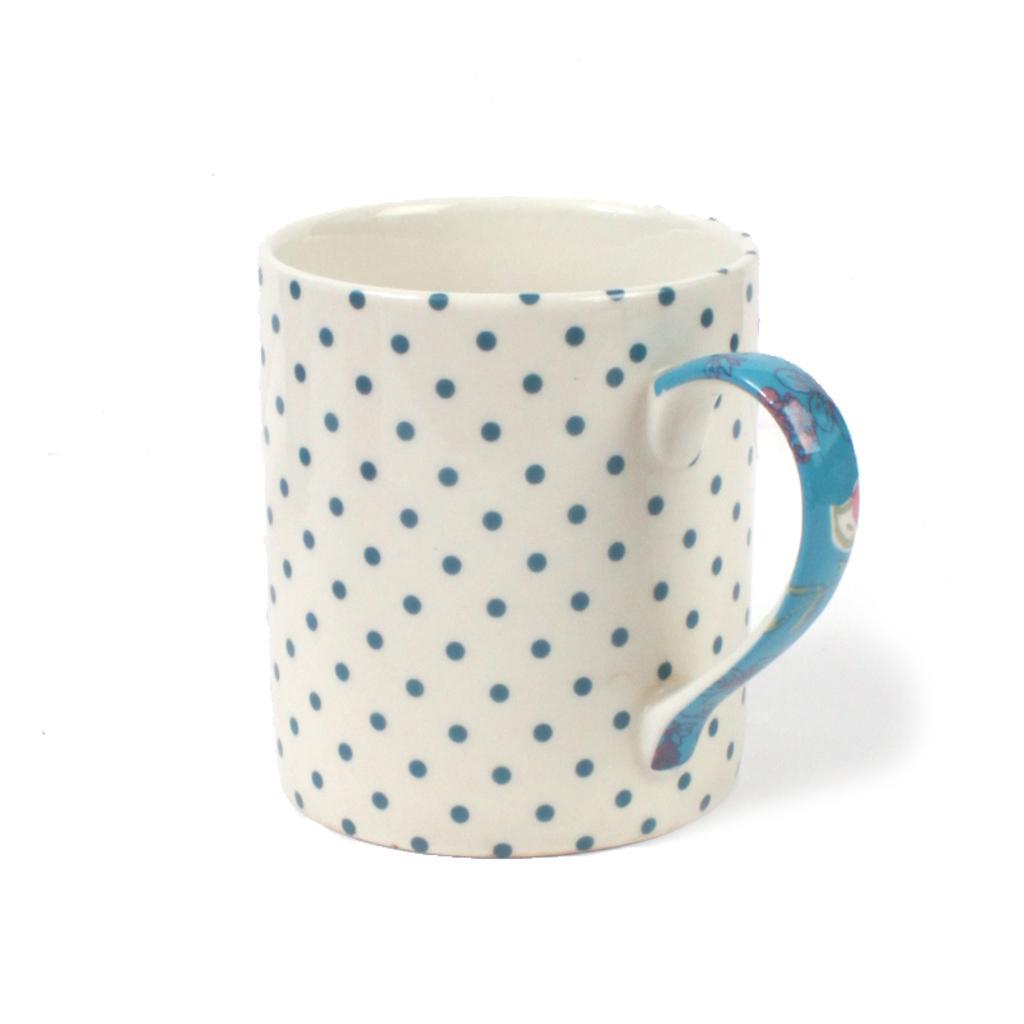Please provide a concise description of this image. In this image there is a cup. On the cup there are dots. 